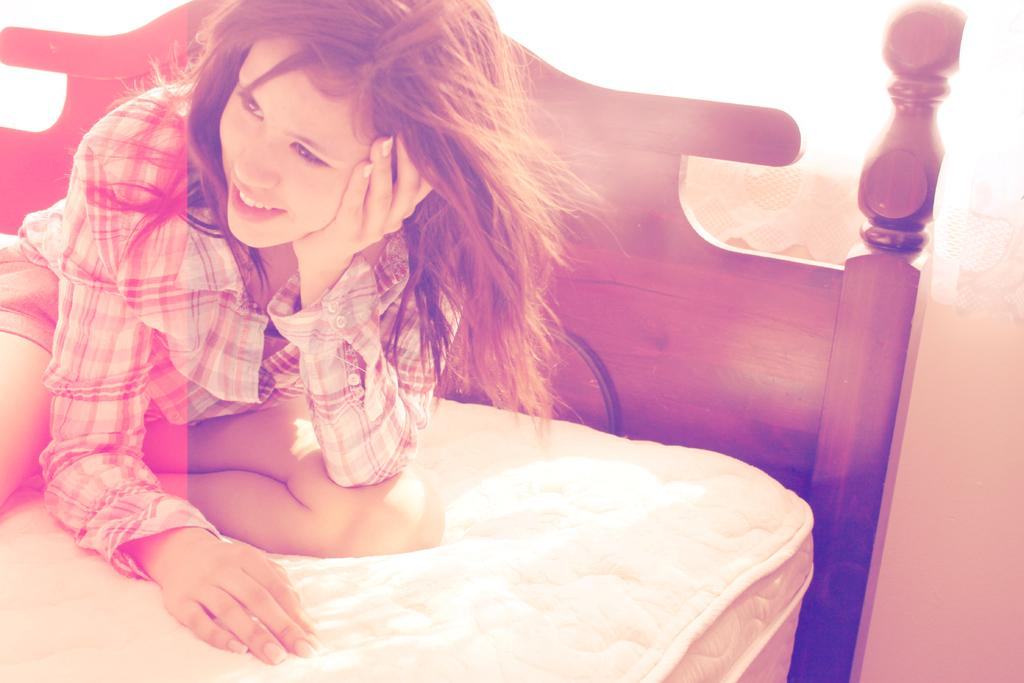Who is present in the image? There is a woman in the image. Where is the woman located? The woman is on a bed. What color is the flame on the woman's hand in the image? There is no flame present on the woman's hand in the image. 